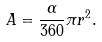<formula> <loc_0><loc_0><loc_500><loc_500>A = { \frac { \alpha } { 3 6 0 } } \pi r ^ { 2 } .</formula> 